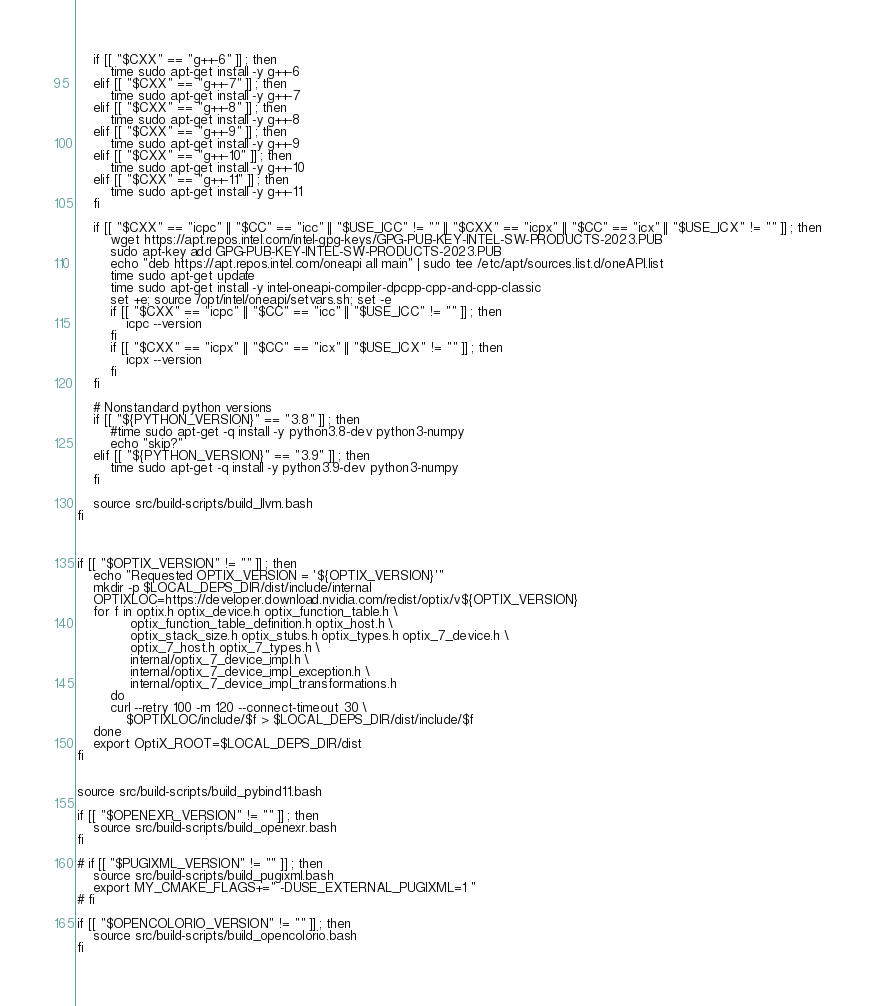Convert code to text. <code><loc_0><loc_0><loc_500><loc_500><_Bash_>    if [[ "$CXX" == "g++-6" ]] ; then
        time sudo apt-get install -y g++-6
    elif [[ "$CXX" == "g++-7" ]] ; then
        time sudo apt-get install -y g++-7
    elif [[ "$CXX" == "g++-8" ]] ; then
        time sudo apt-get install -y g++-8
    elif [[ "$CXX" == "g++-9" ]] ; then
        time sudo apt-get install -y g++-9
    elif [[ "$CXX" == "g++-10" ]] ; then
        time sudo apt-get install -y g++-10
    elif [[ "$CXX" == "g++-11" ]] ; then
        time sudo apt-get install -y g++-11
    fi

    if [[ "$CXX" == "icpc" || "$CC" == "icc" || "$USE_ICC" != "" || "$CXX" == "icpx" || "$CC" == "icx" || "$USE_ICX" != "" ]] ; then
        wget https://apt.repos.intel.com/intel-gpg-keys/GPG-PUB-KEY-INTEL-SW-PRODUCTS-2023.PUB
        sudo apt-key add GPG-PUB-KEY-INTEL-SW-PRODUCTS-2023.PUB
        echo "deb https://apt.repos.intel.com/oneapi all main" | sudo tee /etc/apt/sources.list.d/oneAPI.list
        time sudo apt-get update
        time sudo apt-get install -y intel-oneapi-compiler-dpcpp-cpp-and-cpp-classic
        set +e; source /opt/intel/oneapi/setvars.sh; set -e
        if [[ "$CXX" == "icpc" || "$CC" == "icc" || "$USE_ICC" != "" ]] ; then
            icpc --version
        fi
        if [[ "$CXX" == "icpx" || "$CC" == "icx" || "$USE_ICX" != "" ]] ; then
            icpx --version
        fi
    fi

    # Nonstandard python versions
    if [[ "${PYTHON_VERSION}" == "3.8" ]] ; then
        #time sudo apt-get -q install -y python3.8-dev python3-numpy
        echo "skip?"
    elif [[ "${PYTHON_VERSION}" == "3.9" ]] ; then
        time sudo apt-get -q install -y python3.9-dev python3-numpy
    fi

    source src/build-scripts/build_llvm.bash
fi



if [[ "$OPTIX_VERSION" != "" ]] ; then
    echo "Requested OPTIX_VERSION = '${OPTIX_VERSION}'"
    mkdir -p $LOCAL_DEPS_DIR/dist/include/internal
    OPTIXLOC=https://developer.download.nvidia.com/redist/optix/v${OPTIX_VERSION}
    for f in optix.h optix_device.h optix_function_table.h \
             optix_function_table_definition.h optix_host.h \
             optix_stack_size.h optix_stubs.h optix_types.h optix_7_device.h \
             optix_7_host.h optix_7_types.h \
             internal/optix_7_device_impl.h \
             internal/optix_7_device_impl_exception.h \
             internal/optix_7_device_impl_transformations.h
        do
        curl --retry 100 -m 120 --connect-timeout 30 \
            $OPTIXLOC/include/$f > $LOCAL_DEPS_DIR/dist/include/$f
    done
    export OptiX_ROOT=$LOCAL_DEPS_DIR/dist
fi


source src/build-scripts/build_pybind11.bash

if [[ "$OPENEXR_VERSION" != "" ]] ; then
    source src/build-scripts/build_openexr.bash
fi

# if [[ "$PUGIXML_VERSION" != "" ]] ; then
    source src/build-scripts/build_pugixml.bash
    export MY_CMAKE_FLAGS+=" -DUSE_EXTERNAL_PUGIXML=1 "
# fi

if [[ "$OPENCOLORIO_VERSION" != "" ]] ; then
    source src/build-scripts/build_opencolorio.bash
fi
</code> 